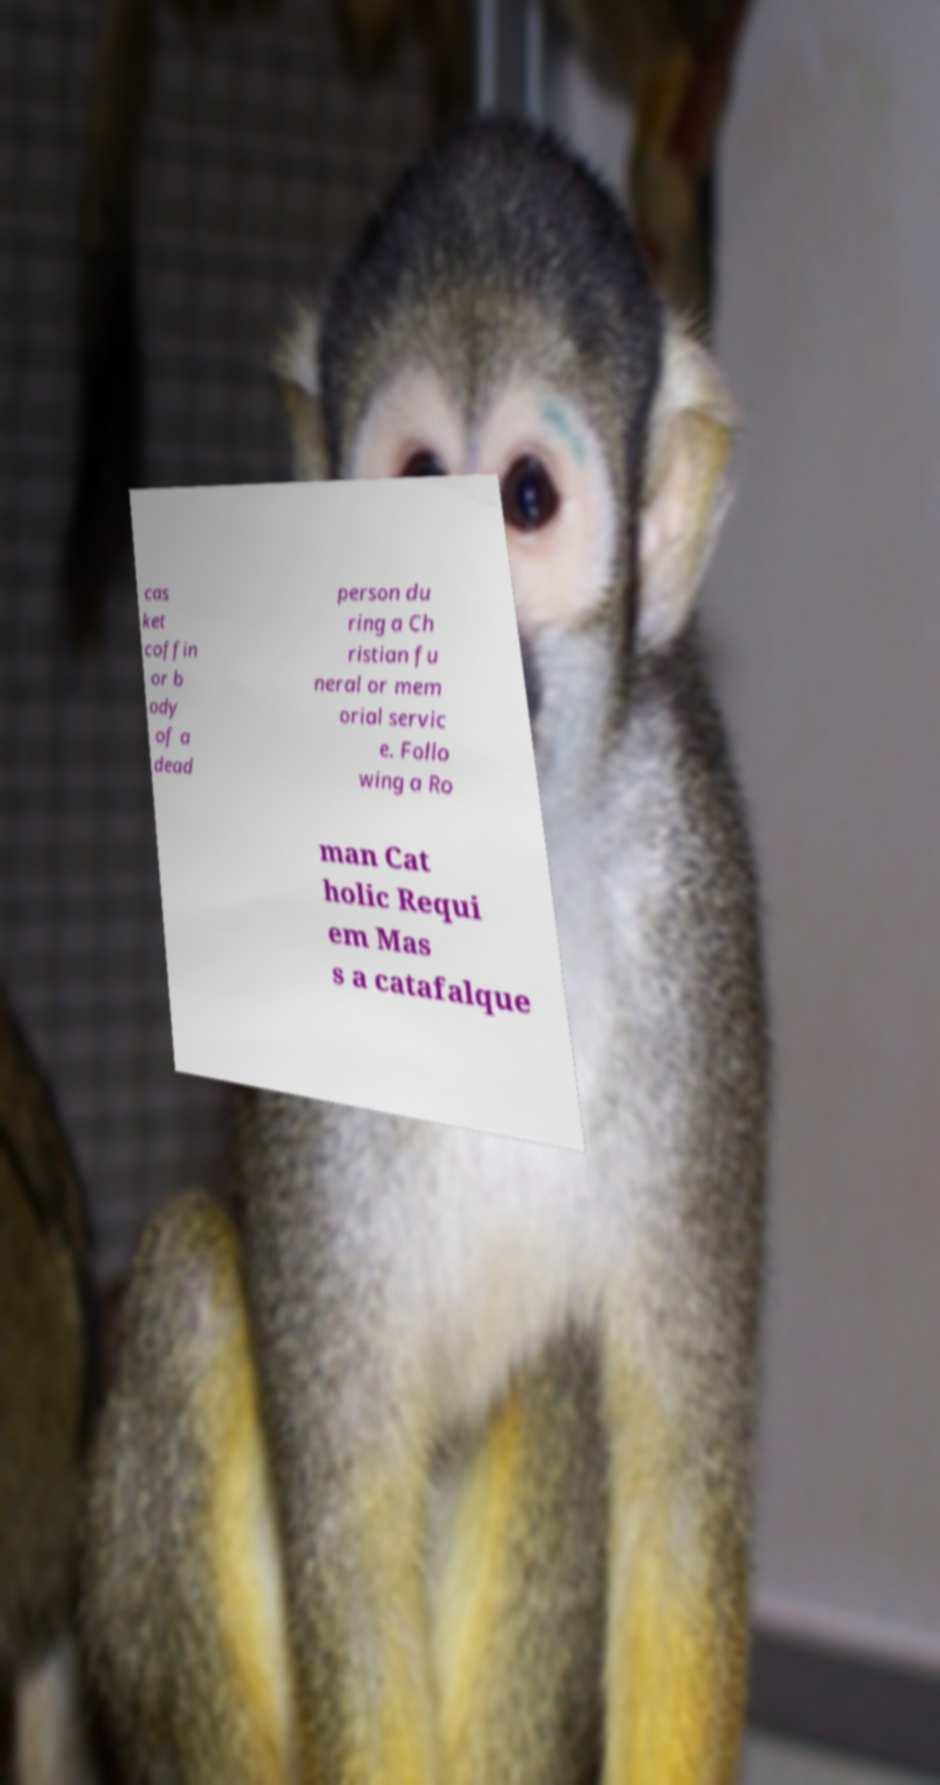For documentation purposes, I need the text within this image transcribed. Could you provide that? cas ket coffin or b ody of a dead person du ring a Ch ristian fu neral or mem orial servic e. Follo wing a Ro man Cat holic Requi em Mas s a catafalque 